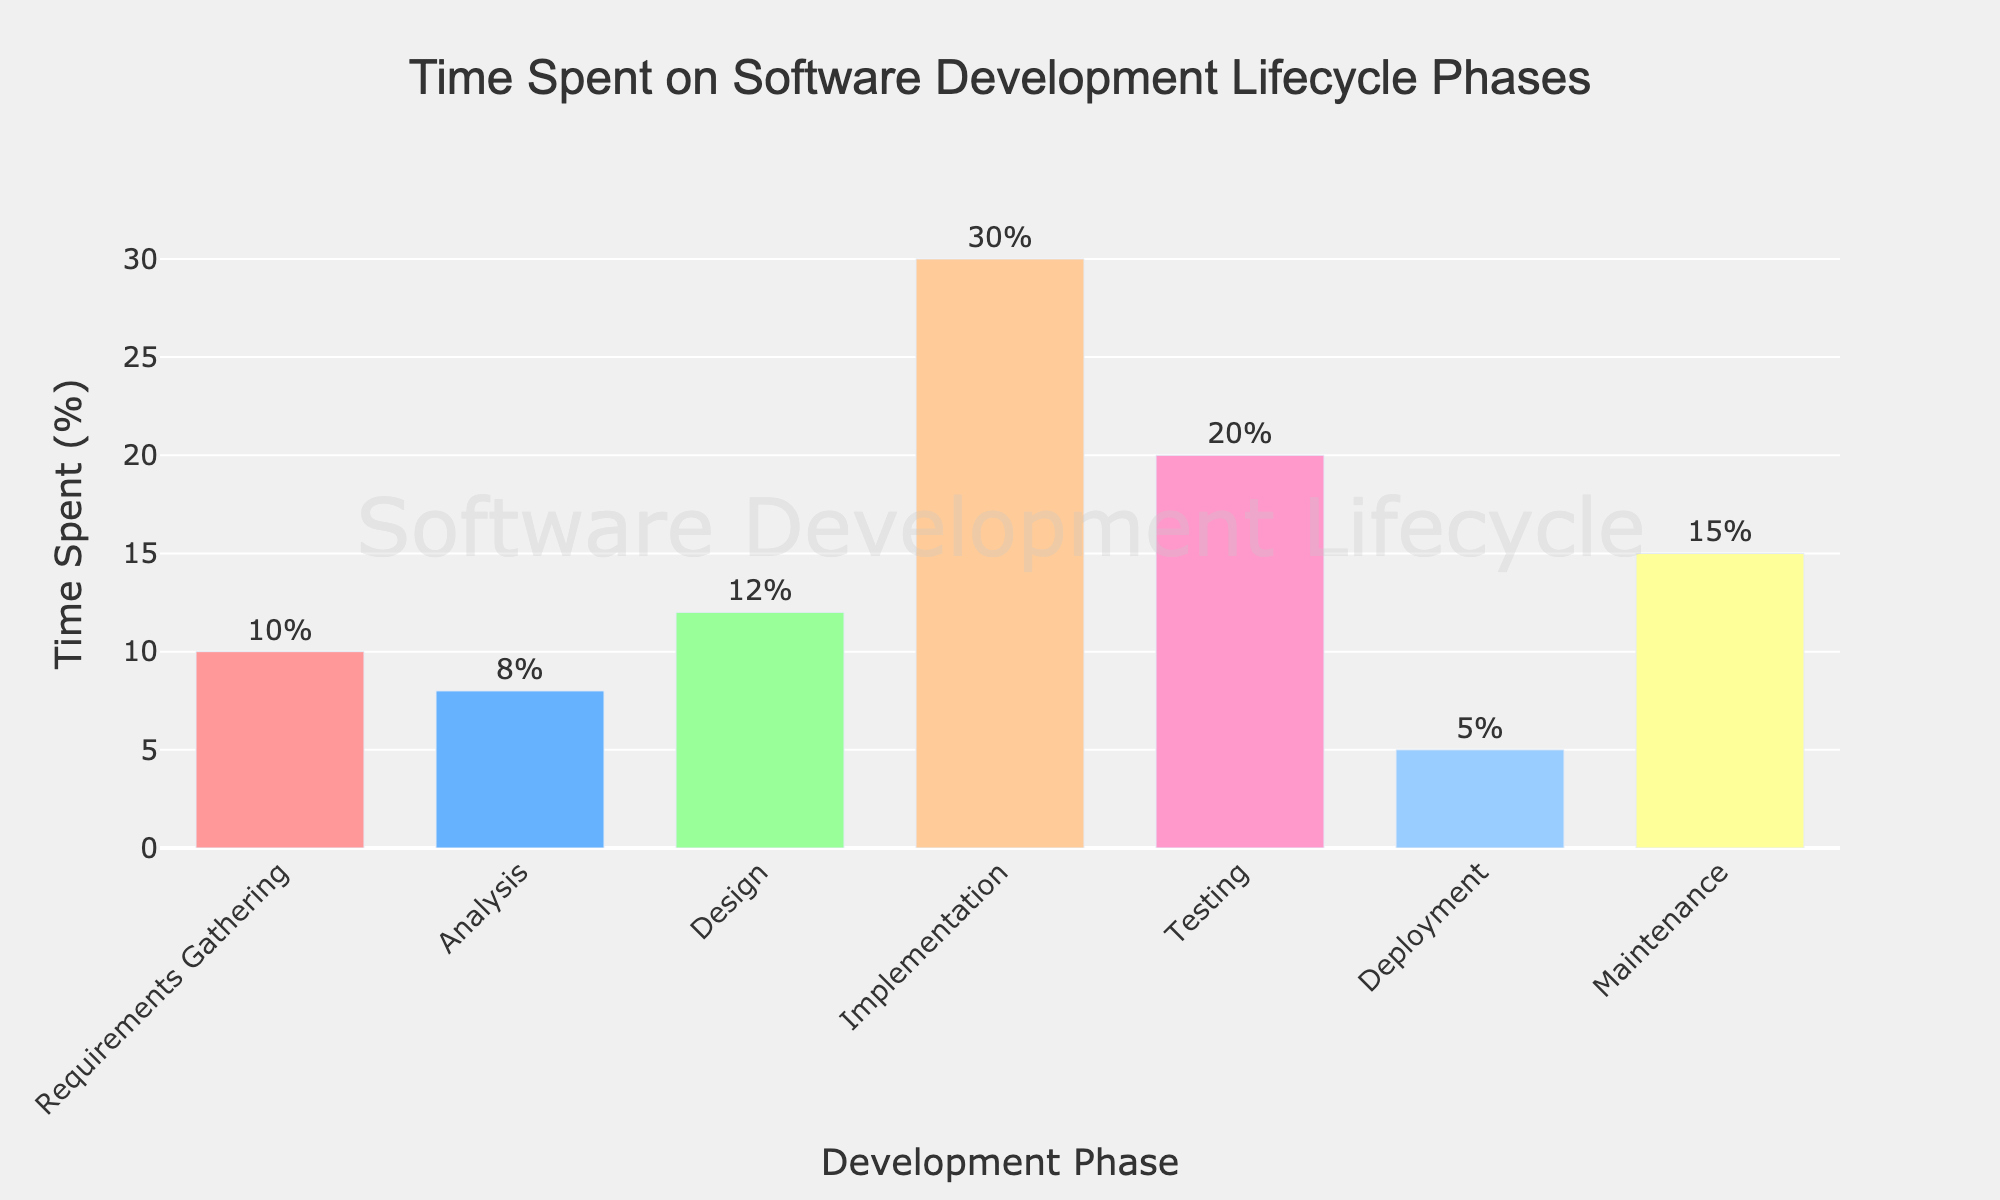What phase takes the longest time in the software development lifecycle? By looking at the height of the bars, the Implementation phase has the tallest bar, thus it takes the longest time.
Answer: Implementation How much more time is spent on Implementation compared to Design? The bar for Implementation represents 30%, and the bar for Design represents 12%. The difference is 30% - 12% = 18%.
Answer: 18% What is the total percentage of time spent on Testing and Maintenance combined? The bar for Testing shows 20%, and the bar for Maintenance shows 15%. Adding these together, 20% + 15% = 35%.
Answer: 35% How does the time spent on Deployment compare to the time spent on Analysis? The bar for Deployment is 5%, while the bar for Analysis is 8%. Thus, Deployment takes 3% less time than Analysis.
Answer: 3% less What is the average time spent across all phases of the software development lifecycle? Adding all the time percentages together: 10% + 8% + 12% + 30% + 20% + 5% + 15% = 100%. There are 7 phases, so the average is 100% / 7 ≈ 14.29%.
Answer: 14.29% Which phases spend less than 10% of the total time? By looking at the bars, both Requirements Gathering (10%), Analysis (8%), and Deployment (5%) require checking. Only the Analysis and Deployment phases meet the criteria.
Answer: Analysis, Deployment How much total time is spent on phases that are categorized as Testing or later? The Testing, Deployment, and Maintenance phases have bars representing 20%, 5%, and 15%, respectively. Adding these together, 20% + 5% + 15% = 40%.
Answer: 40% Which phase has a time percentage closest to twice the time of Requirements Gathering? Requirements Gathering is 10%. Twice this is 10% * 2 = 20%. The Testing phase has a bar representing 20%, which is closest to this value.
Answer: Testing What is the color of the bar representing the Deployment phase? By examining the colors, the Deployment phase bar is shown in purple/pink.
Answer: Purple/Pink Is the time spent on Maintenance greater than the sum of the times spent on Deployment and Analysis? The Maintenance phase has 15%, Deployment has 5%, and Analysis has 8%. The sum of Deployment and Analysis is 5% + 8% = 13%. Since 15% > 13%, the time spent on Maintenance is indeed greater.
Answer: Yes 